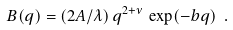<formula> <loc_0><loc_0><loc_500><loc_500>B ( q ) = ( 2 A / \lambda ) \, q ^ { 2 + \nu } \, \exp ( - b q ) \ .</formula> 